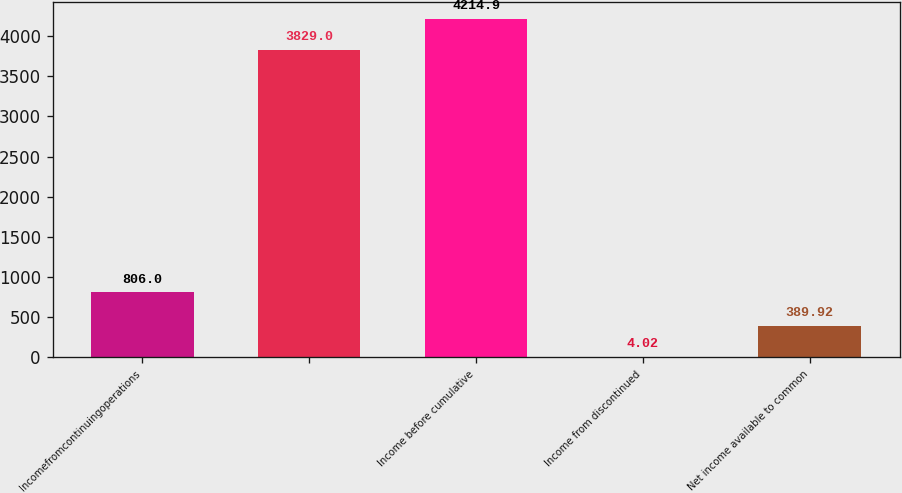<chart> <loc_0><loc_0><loc_500><loc_500><bar_chart><fcel>Incomefromcontinuingoperations<fcel>Unnamed: 1<fcel>Income before cumulative<fcel>Income from discontinued<fcel>Net income available to common<nl><fcel>806<fcel>3829<fcel>4214.9<fcel>4.02<fcel>389.92<nl></chart> 